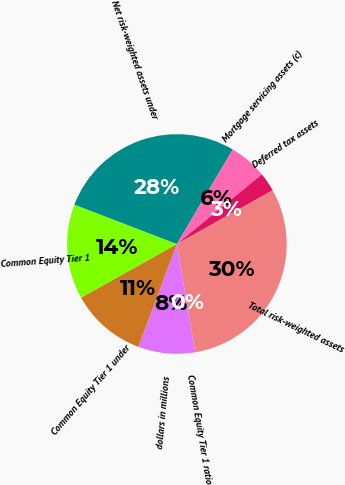Convert chart to OTSL. <chart><loc_0><loc_0><loc_500><loc_500><pie_chart><fcel>dollars in millions<fcel>Common Equity Tier 1 under<fcel>Common Equity Tier 1<fcel>Net risk-weighted assets under<fcel>Mortgage servicing assets (c)<fcel>Deferred tax assets<fcel>Total risk-weighted assets<fcel>Common Equity Tier 1 ratio<nl><fcel>8.38%<fcel>11.17%<fcel>13.96%<fcel>27.66%<fcel>5.58%<fcel>2.79%<fcel>30.45%<fcel>0.0%<nl></chart> 